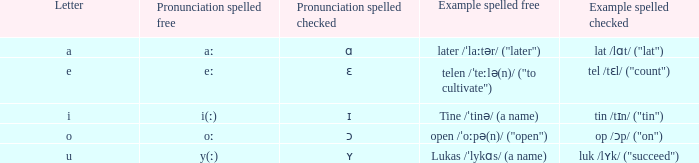How can pronunciation spelled free be defined when pronunciation spelled checked equals "ɛ"? Eː. 